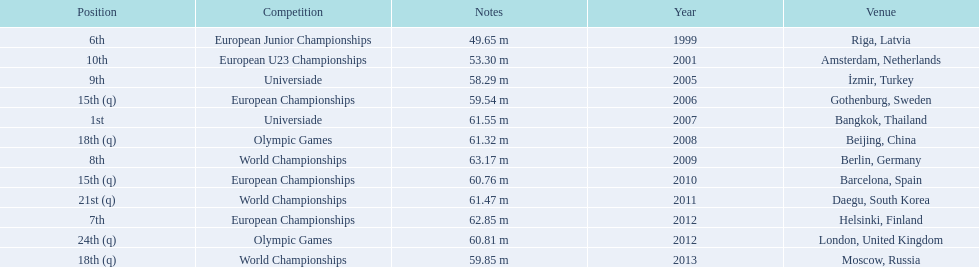What european junior championships? 6th. What waseuropean junior championships best result? 63.17 m. 